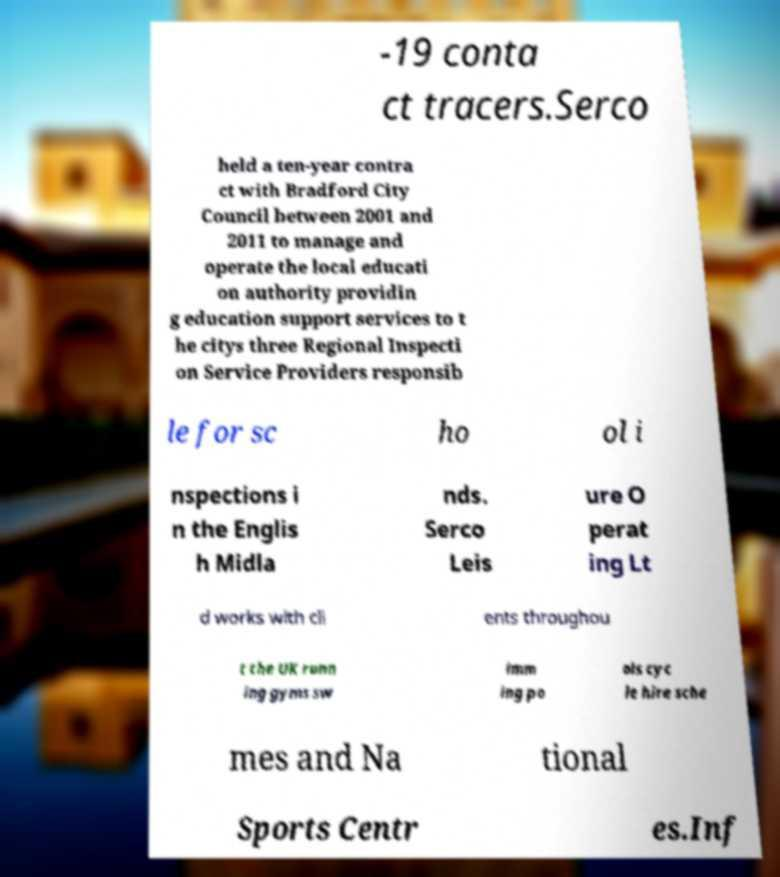There's text embedded in this image that I need extracted. Can you transcribe it verbatim? -19 conta ct tracers.Serco held a ten-year contra ct with Bradford City Council between 2001 and 2011 to manage and operate the local educati on authority providin g education support services to t he citys three Regional Inspecti on Service Providers responsib le for sc ho ol i nspections i n the Englis h Midla nds. Serco Leis ure O perat ing Lt d works with cli ents throughou t the UK runn ing gyms sw imm ing po ols cyc le hire sche mes and Na tional Sports Centr es.Inf 